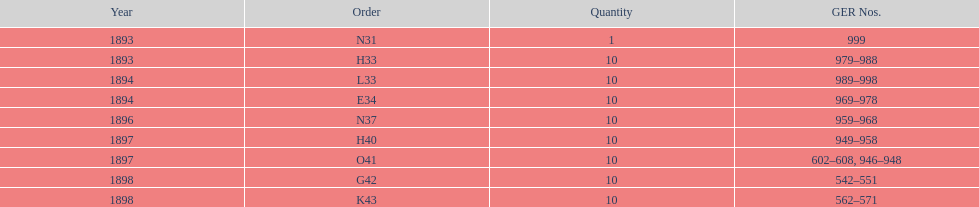What amount of time to the years span? 5 years. 